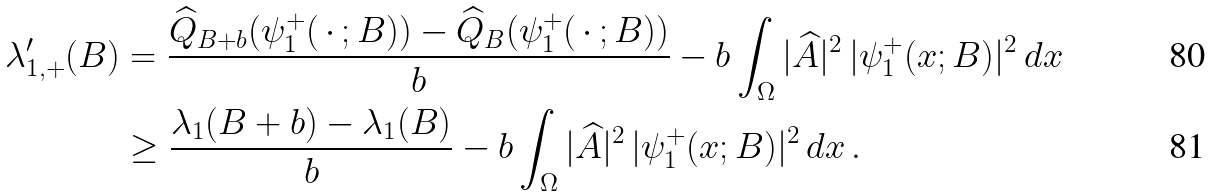Convert formula to latex. <formula><loc_0><loc_0><loc_500><loc_500>\lambda _ { 1 , + } ^ { \prime } ( B ) & = \frac { \widehat { Q } _ { B + b } ( \psi ^ { + } _ { 1 } ( \, \cdot \, ; B ) ) - \widehat { Q } _ { B } ( \psi ^ { + } _ { 1 } ( \, \cdot \, ; B ) ) } { b } - b \int _ { \Omega } | \widehat { A } | ^ { 2 } \, | \psi ^ { + } _ { 1 } ( x ; B ) | ^ { 2 } \, d x \\ & \geq \frac { \lambda _ { 1 } ( B + b ) - \lambda _ { 1 } ( B ) } { b } - b \int _ { \Omega } | \widehat { A } | ^ { 2 } \, | \psi ^ { + } _ { 1 } ( x ; B ) | ^ { 2 } \, d x \, .</formula> 